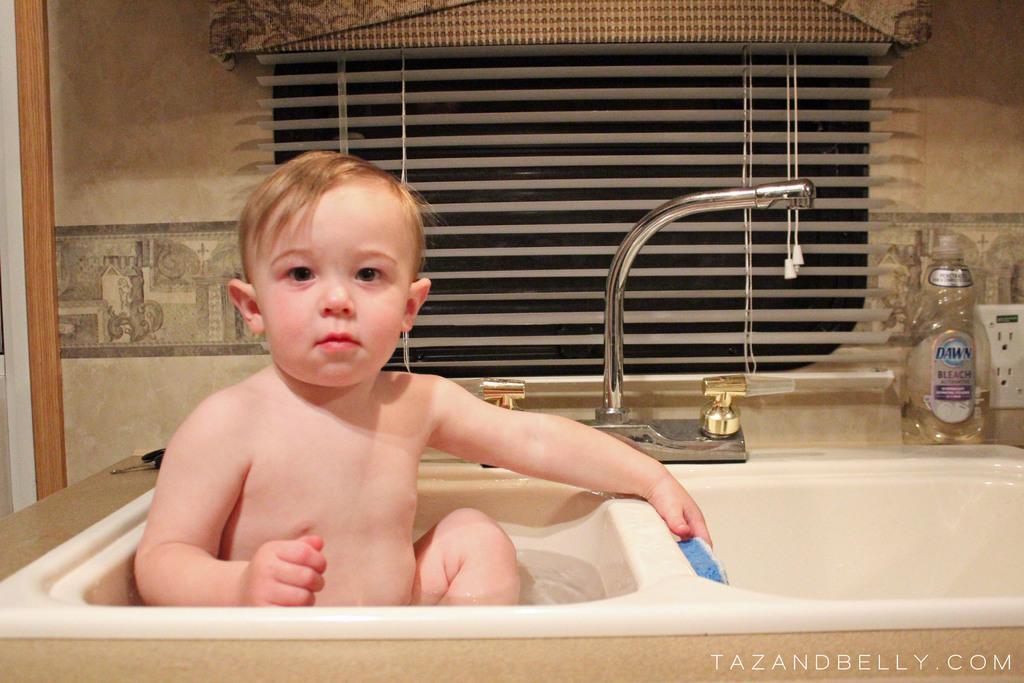Could you give a brief overview of what you see in this image? In this image I can see two sinks and in one sink I can see water and a boy. I can see he is holding a brush and in the background I can see a water tap, a bottle, two power sockets and the window blind. On the bottom right side of this image I can see a watermark. 